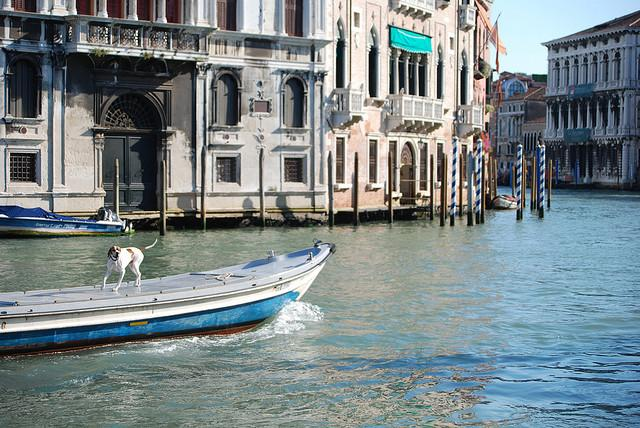What are these waterways equivalent in usage to in other cities and countries? Please explain your reasoning. streets. They're streets. 